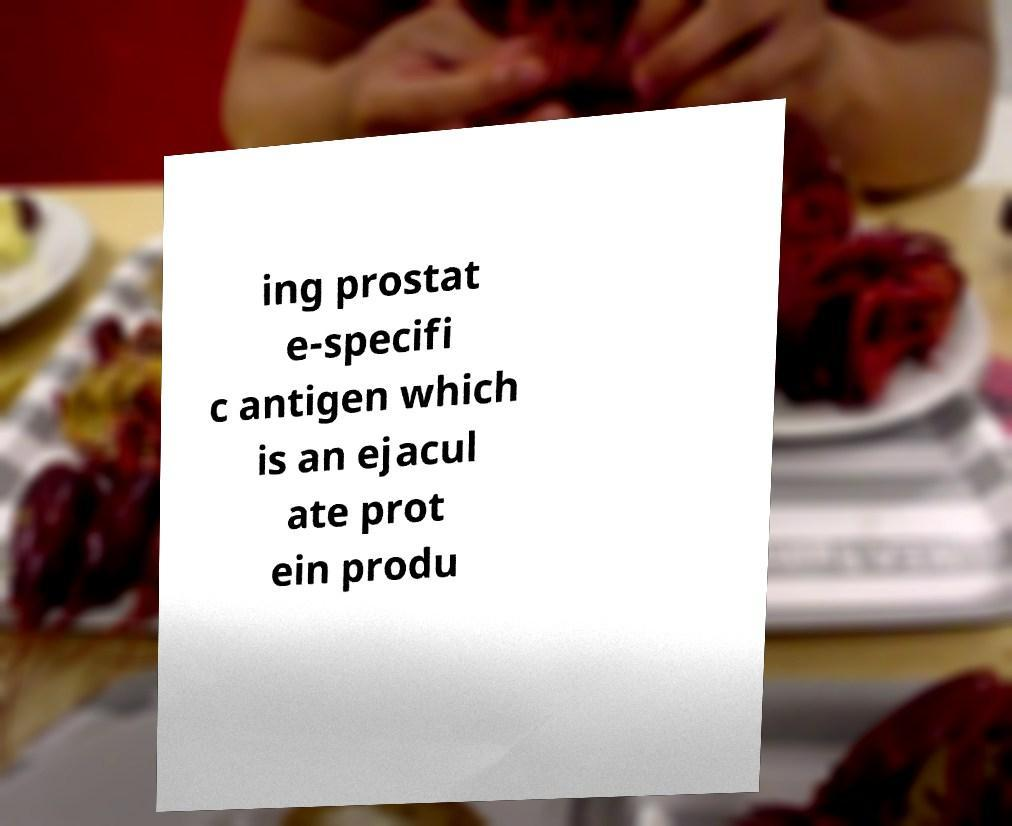Could you assist in decoding the text presented in this image and type it out clearly? ing prostat e-specifi c antigen which is an ejacul ate prot ein produ 